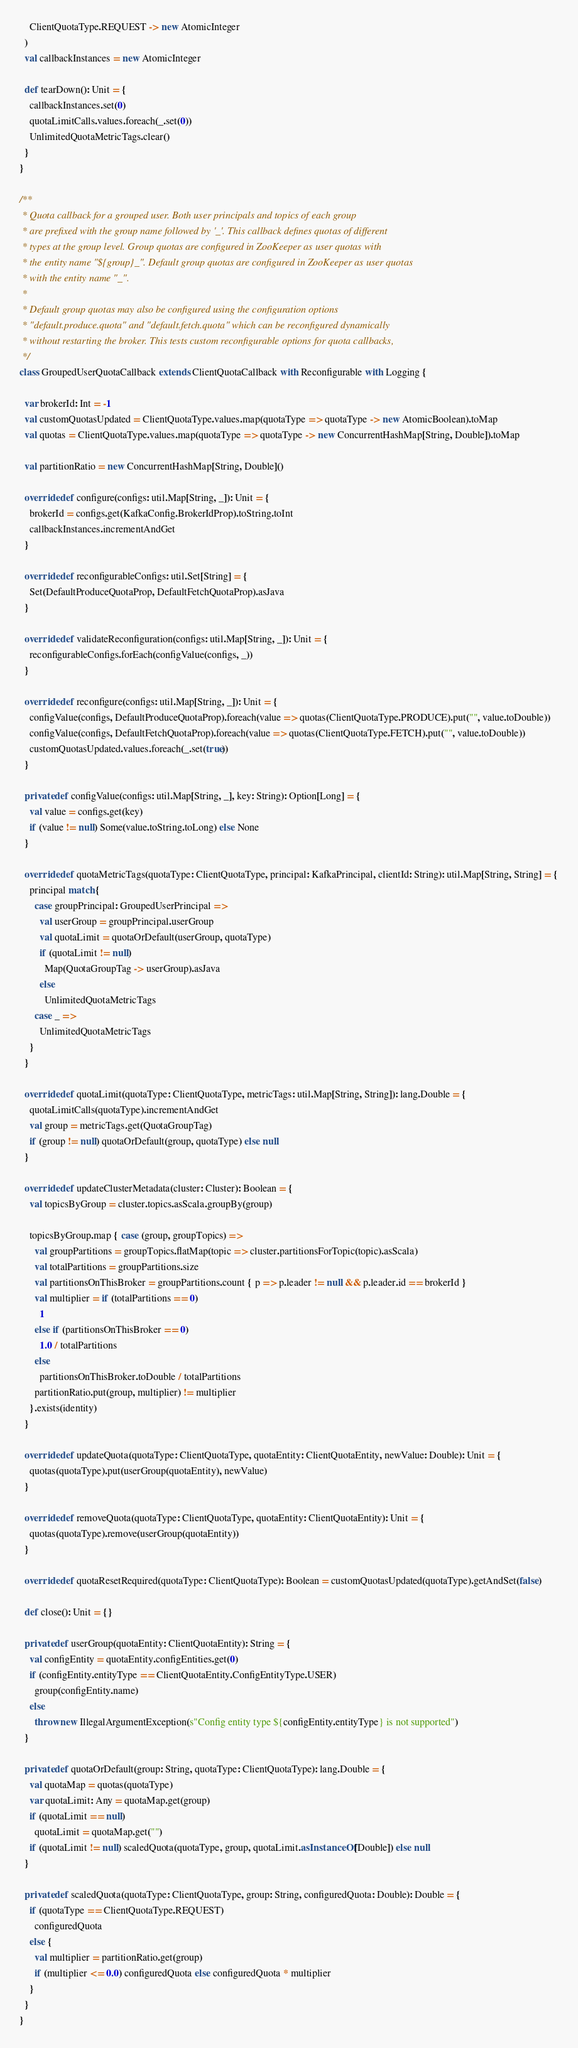Convert code to text. <code><loc_0><loc_0><loc_500><loc_500><_Scala_>    ClientQuotaType.REQUEST -> new AtomicInteger
  )
  val callbackInstances = new AtomicInteger

  def tearDown(): Unit = {
    callbackInstances.set(0)
    quotaLimitCalls.values.foreach(_.set(0))
    UnlimitedQuotaMetricTags.clear()
  }
}

/**
 * Quota callback for a grouped user. Both user principals and topics of each group
 * are prefixed with the group name followed by '_'. This callback defines quotas of different
 * types at the group level. Group quotas are configured in ZooKeeper as user quotas with
 * the entity name "${group}_". Default group quotas are configured in ZooKeeper as user quotas
 * with the entity name "_".
 *
 * Default group quotas may also be configured using the configuration options
 * "default.produce.quota" and "default.fetch.quota" which can be reconfigured dynamically
 * without restarting the broker. This tests custom reconfigurable options for quota callbacks,
 */
class GroupedUserQuotaCallback extends ClientQuotaCallback with Reconfigurable with Logging {

  var brokerId: Int = -1
  val customQuotasUpdated = ClientQuotaType.values.map(quotaType => quotaType -> new AtomicBoolean).toMap
  val quotas = ClientQuotaType.values.map(quotaType => quotaType -> new ConcurrentHashMap[String, Double]).toMap

  val partitionRatio = new ConcurrentHashMap[String, Double]()

  override def configure(configs: util.Map[String, _]): Unit = {
    brokerId = configs.get(KafkaConfig.BrokerIdProp).toString.toInt
    callbackInstances.incrementAndGet
  }

  override def reconfigurableConfigs: util.Set[String] = {
    Set(DefaultProduceQuotaProp, DefaultFetchQuotaProp).asJava
  }

  override def validateReconfiguration(configs: util.Map[String, _]): Unit = {
    reconfigurableConfigs.forEach(configValue(configs, _))
  }

  override def reconfigure(configs: util.Map[String, _]): Unit = {
    configValue(configs, DefaultProduceQuotaProp).foreach(value => quotas(ClientQuotaType.PRODUCE).put("", value.toDouble))
    configValue(configs, DefaultFetchQuotaProp).foreach(value => quotas(ClientQuotaType.FETCH).put("", value.toDouble))
    customQuotasUpdated.values.foreach(_.set(true))
  }

  private def configValue(configs: util.Map[String, _], key: String): Option[Long] = {
    val value = configs.get(key)
    if (value != null) Some(value.toString.toLong) else None
  }

  override def quotaMetricTags(quotaType: ClientQuotaType, principal: KafkaPrincipal, clientId: String): util.Map[String, String] = {
    principal match {
      case groupPrincipal: GroupedUserPrincipal =>
        val userGroup = groupPrincipal.userGroup
        val quotaLimit = quotaOrDefault(userGroup, quotaType)
        if (quotaLimit != null)
          Map(QuotaGroupTag -> userGroup).asJava
        else
          UnlimitedQuotaMetricTags
      case _ =>
        UnlimitedQuotaMetricTags
    }
  }

  override def quotaLimit(quotaType: ClientQuotaType, metricTags: util.Map[String, String]): lang.Double = {
    quotaLimitCalls(quotaType).incrementAndGet
    val group = metricTags.get(QuotaGroupTag)
    if (group != null) quotaOrDefault(group, quotaType) else null
  }

  override def updateClusterMetadata(cluster: Cluster): Boolean = {
    val topicsByGroup = cluster.topics.asScala.groupBy(group)

    topicsByGroup.map { case (group, groupTopics) =>
      val groupPartitions = groupTopics.flatMap(topic => cluster.partitionsForTopic(topic).asScala)
      val totalPartitions = groupPartitions.size
      val partitionsOnThisBroker = groupPartitions.count { p => p.leader != null && p.leader.id == brokerId }
      val multiplier = if (totalPartitions == 0)
        1
      else if (partitionsOnThisBroker == 0)
        1.0 / totalPartitions
      else
        partitionsOnThisBroker.toDouble / totalPartitions
      partitionRatio.put(group, multiplier) != multiplier
    }.exists(identity)
  }

  override def updateQuota(quotaType: ClientQuotaType, quotaEntity: ClientQuotaEntity, newValue: Double): Unit = {
    quotas(quotaType).put(userGroup(quotaEntity), newValue)
  }

  override def removeQuota(quotaType: ClientQuotaType, quotaEntity: ClientQuotaEntity): Unit = {
    quotas(quotaType).remove(userGroup(quotaEntity))
  }

  override def quotaResetRequired(quotaType: ClientQuotaType): Boolean = customQuotasUpdated(quotaType).getAndSet(false)

  def close(): Unit = {}

  private def userGroup(quotaEntity: ClientQuotaEntity): String = {
    val configEntity = quotaEntity.configEntities.get(0)
    if (configEntity.entityType == ClientQuotaEntity.ConfigEntityType.USER)
      group(configEntity.name)
    else
      throw new IllegalArgumentException(s"Config entity type ${configEntity.entityType} is not supported")
  }

  private def quotaOrDefault(group: String, quotaType: ClientQuotaType): lang.Double = {
    val quotaMap = quotas(quotaType)
    var quotaLimit: Any = quotaMap.get(group)
    if (quotaLimit == null)
      quotaLimit = quotaMap.get("")
    if (quotaLimit != null) scaledQuota(quotaType, group, quotaLimit.asInstanceOf[Double]) else null
  }

  private def scaledQuota(quotaType: ClientQuotaType, group: String, configuredQuota: Double): Double = {
    if (quotaType == ClientQuotaType.REQUEST)
      configuredQuota
    else {
      val multiplier = partitionRatio.get(group)
      if (multiplier <= 0.0) configuredQuota else configuredQuota * multiplier
    }
  }
}


</code> 